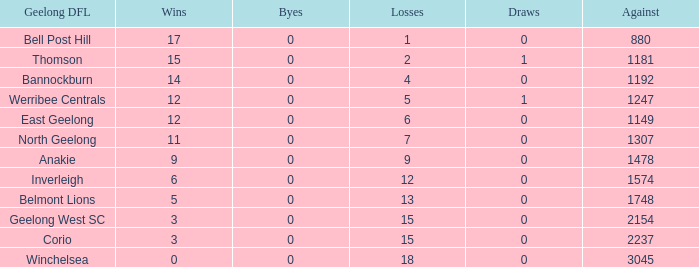What is the average of wins when the byes are less than 0? None. 